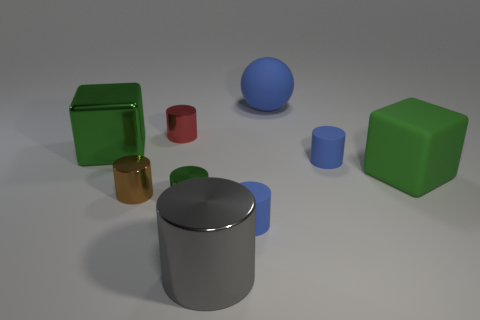Subtract all red metal cylinders. How many cylinders are left? 5 Subtract all brown cylinders. How many cylinders are left? 5 Subtract all yellow cylinders. How many yellow blocks are left? 0 Subtract all big blue things. Subtract all metallic cylinders. How many objects are left? 4 Add 3 rubber cubes. How many rubber cubes are left? 4 Add 3 small blue matte objects. How many small blue matte objects exist? 5 Add 1 blue matte things. How many objects exist? 10 Subtract 0 yellow spheres. How many objects are left? 9 Subtract all cubes. How many objects are left? 7 Subtract 1 balls. How many balls are left? 0 